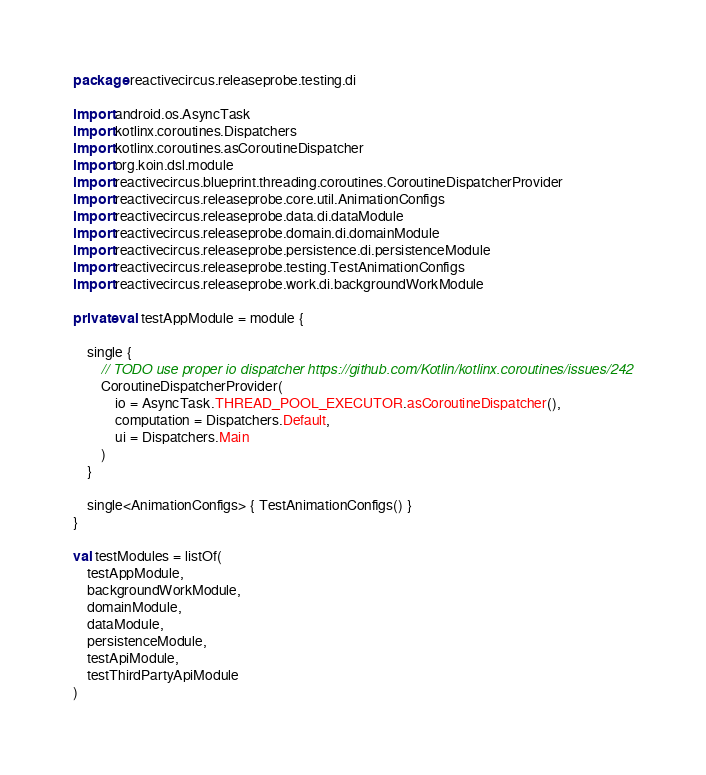Convert code to text. <code><loc_0><loc_0><loc_500><loc_500><_Kotlin_>package reactivecircus.releaseprobe.testing.di

import android.os.AsyncTask
import kotlinx.coroutines.Dispatchers
import kotlinx.coroutines.asCoroutineDispatcher
import org.koin.dsl.module
import reactivecircus.blueprint.threading.coroutines.CoroutineDispatcherProvider
import reactivecircus.releaseprobe.core.util.AnimationConfigs
import reactivecircus.releaseprobe.data.di.dataModule
import reactivecircus.releaseprobe.domain.di.domainModule
import reactivecircus.releaseprobe.persistence.di.persistenceModule
import reactivecircus.releaseprobe.testing.TestAnimationConfigs
import reactivecircus.releaseprobe.work.di.backgroundWorkModule

private val testAppModule = module {

    single {
        // TODO use proper io dispatcher https://github.com/Kotlin/kotlinx.coroutines/issues/242
        CoroutineDispatcherProvider(
            io = AsyncTask.THREAD_POOL_EXECUTOR.asCoroutineDispatcher(),
            computation = Dispatchers.Default,
            ui = Dispatchers.Main
        )
    }

    single<AnimationConfigs> { TestAnimationConfigs() }
}

val testModules = listOf(
    testAppModule,
    backgroundWorkModule,
    domainModule,
    dataModule,
    persistenceModule,
    testApiModule,
    testThirdPartyApiModule
)
</code> 